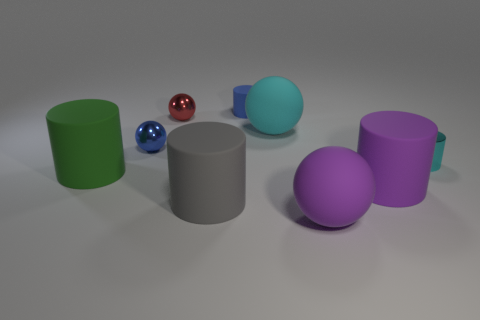Subtract all small blue matte cylinders. How many cylinders are left? 4 Subtract all cyan cylinders. How many cylinders are left? 4 Subtract 1 spheres. How many spheres are left? 3 Subtract all brown cylinders. Subtract all gray blocks. How many cylinders are left? 5 Add 1 green rubber cylinders. How many objects exist? 10 Subtract all cylinders. How many objects are left? 4 Subtract all small yellow spheres. Subtract all red objects. How many objects are left? 8 Add 7 red shiny spheres. How many red shiny spheres are left? 8 Add 1 big metal spheres. How many big metal spheres exist? 1 Subtract 0 cyan blocks. How many objects are left? 9 